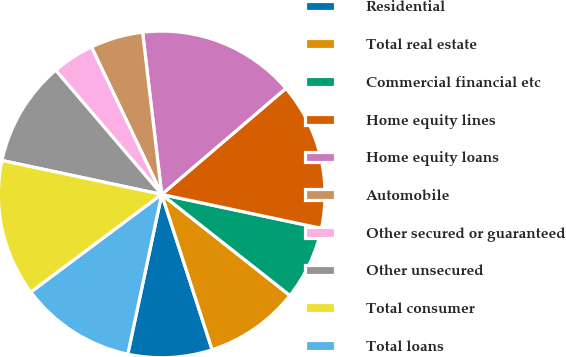<chart> <loc_0><loc_0><loc_500><loc_500><pie_chart><fcel>Residential<fcel>Total real estate<fcel>Commercial financial etc<fcel>Home equity lines<fcel>Home equity loans<fcel>Automobile<fcel>Other secured or guaranteed<fcel>Other unsecured<fcel>Total consumer<fcel>Total loans<nl><fcel>8.33%<fcel>9.38%<fcel>7.29%<fcel>14.58%<fcel>15.62%<fcel>5.21%<fcel>4.17%<fcel>10.42%<fcel>13.54%<fcel>11.46%<nl></chart> 